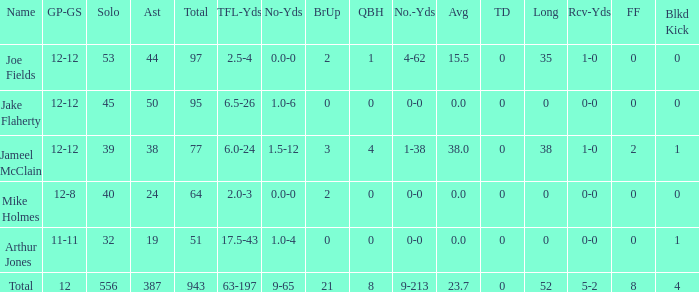How many individuals named jake flaherty in the game? 1.0. 